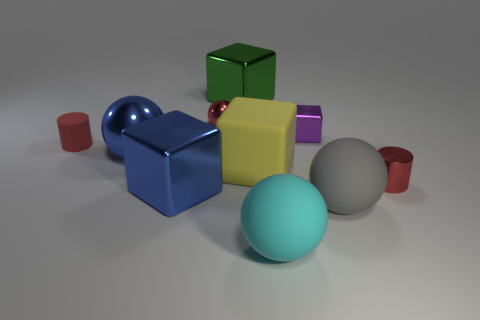Does the metallic cylinder have the same color as the small ball?
Ensure brevity in your answer.  Yes. What is the cylinder on the left side of the large matte ball to the right of the big cyan ball made of?
Your answer should be compact. Rubber. The green block has what size?
Your answer should be compact. Large. There is a red ball that is made of the same material as the tiny purple thing; what size is it?
Provide a short and direct response. Small. Do the red object behind the red rubber thing and the cyan rubber object have the same size?
Offer a terse response. No. What is the shape of the matte object that is on the left side of the blue thing that is behind the big shiny object that is in front of the red shiny cylinder?
Give a very brief answer. Cylinder. What number of objects are tiny red things or red objects that are on the right side of the rubber block?
Your answer should be compact. 3. What size is the sphere on the right side of the purple metal object?
Provide a short and direct response. Large. What is the shape of the metal thing that is the same color as the tiny metallic ball?
Your response must be concise. Cylinder. Do the large yellow object and the small red object left of the small shiny sphere have the same material?
Provide a succinct answer. Yes. 